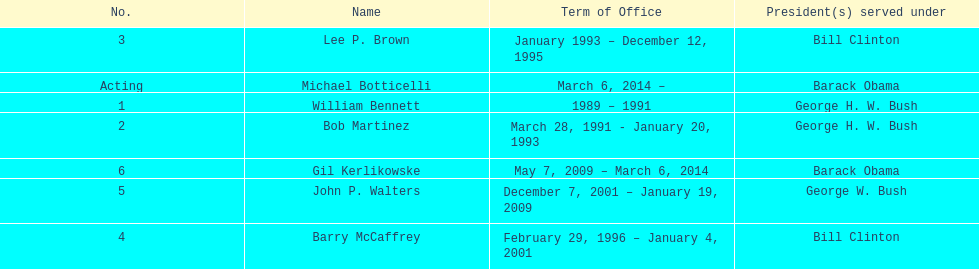Who was the next appointed director after lee p. brown? Barry McCaffrey. 